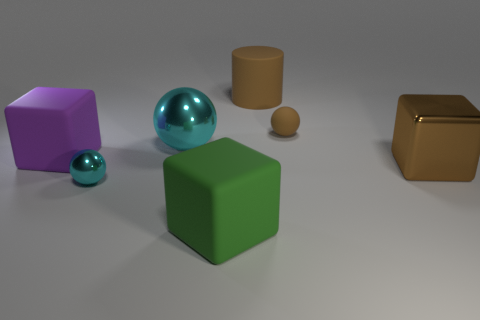Add 2 brown matte objects. How many objects exist? 9 Subtract all cylinders. How many objects are left? 6 Add 1 large cubes. How many large cubes are left? 4 Add 1 blue rubber cylinders. How many blue rubber cylinders exist? 1 Subtract 0 cyan cubes. How many objects are left? 7 Subtract all big purple objects. Subtract all green rubber cubes. How many objects are left? 5 